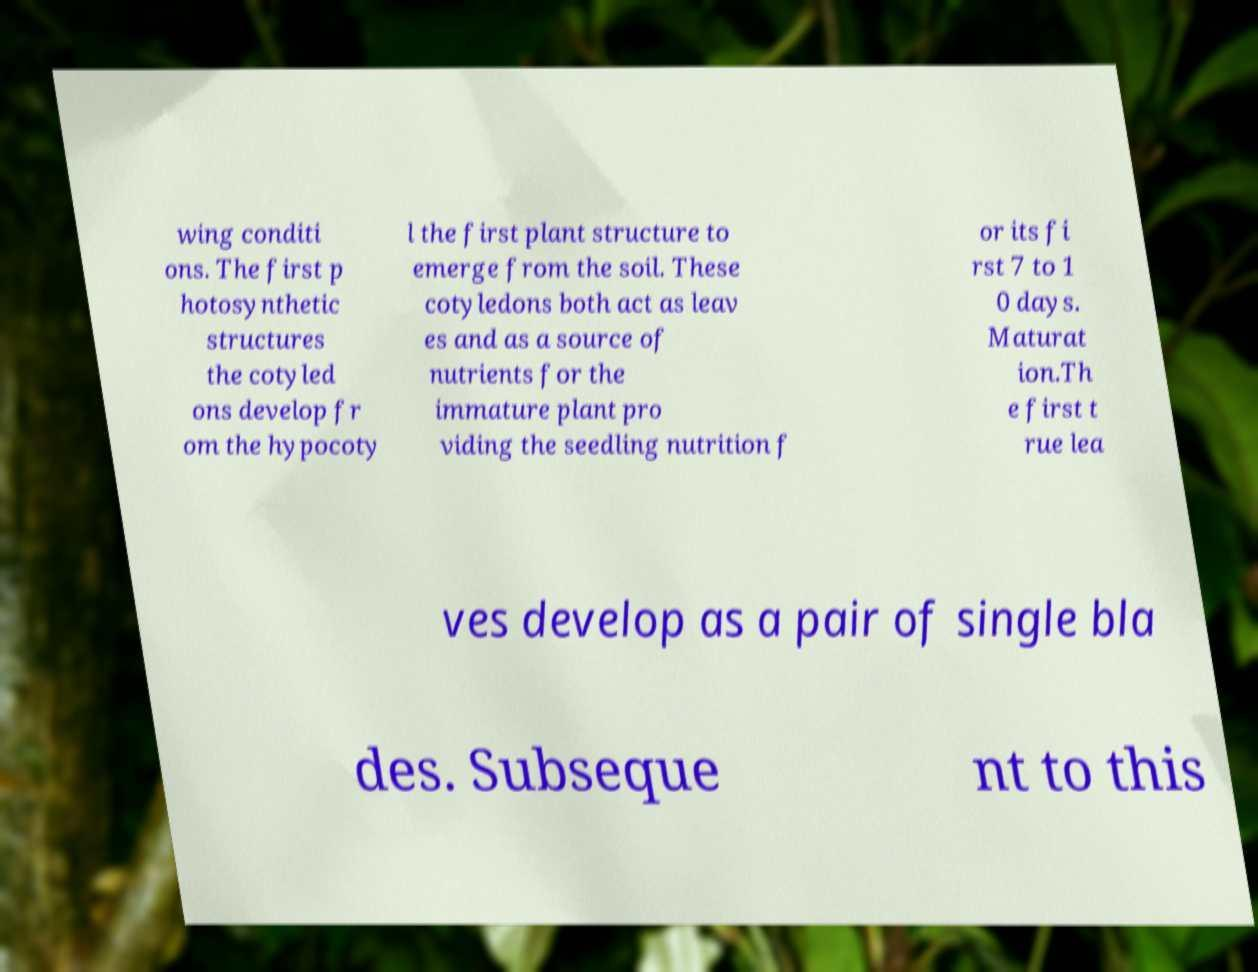I need the written content from this picture converted into text. Can you do that? wing conditi ons. The first p hotosynthetic structures the cotyled ons develop fr om the hypocoty l the first plant structure to emerge from the soil. These cotyledons both act as leav es and as a source of nutrients for the immature plant pro viding the seedling nutrition f or its fi rst 7 to 1 0 days. Maturat ion.Th e first t rue lea ves develop as a pair of single bla des. Subseque nt to this 